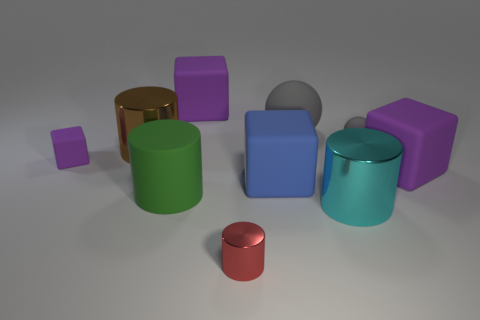What number of other objects are there of the same material as the tiny purple object?
Keep it short and to the point. 6. The metallic thing behind the purple rubber thing right of the red cylinder is what color?
Offer a terse response. Brown. There is a rubber cube to the right of the big blue thing; is it the same color as the tiny rubber block?
Provide a succinct answer. Yes. Do the cyan thing and the red metal thing have the same size?
Offer a very short reply. No. There is a gray matte thing that is the same size as the blue matte block; what shape is it?
Give a very brief answer. Sphere. Does the shiny cylinder that is right of the blue matte thing have the same size as the tiny red cylinder?
Give a very brief answer. No. What is the material of the ball that is the same size as the brown cylinder?
Your answer should be compact. Rubber. Are there any objects that are behind the big cube right of the gray ball that is in front of the big gray object?
Your answer should be compact. Yes. Is there anything else that has the same shape as the big brown object?
Offer a terse response. Yes. Does the tiny rubber object that is on the left side of the tiny red metallic object have the same color as the block that is behind the brown cylinder?
Provide a succinct answer. Yes. 